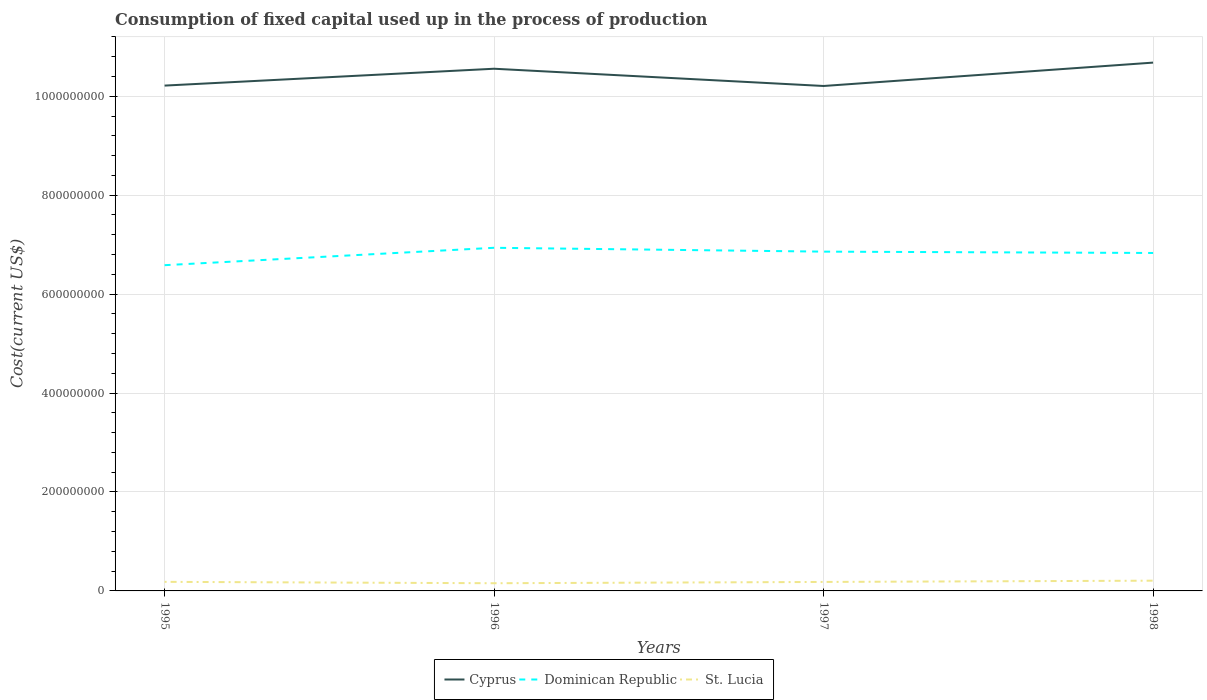Does the line corresponding to Cyprus intersect with the line corresponding to St. Lucia?
Offer a very short reply. No. Across all years, what is the maximum amount consumed in the process of production in Cyprus?
Your answer should be very brief. 1.02e+09. What is the total amount consumed in the process of production in St. Lucia in the graph?
Ensure brevity in your answer.  1.98e+05. What is the difference between the highest and the second highest amount consumed in the process of production in Cyprus?
Give a very brief answer. 4.73e+07. What is the difference between the highest and the lowest amount consumed in the process of production in St. Lucia?
Make the answer very short. 2. Is the amount consumed in the process of production in Cyprus strictly greater than the amount consumed in the process of production in St. Lucia over the years?
Offer a terse response. No. How many years are there in the graph?
Offer a very short reply. 4. What is the difference between two consecutive major ticks on the Y-axis?
Offer a very short reply. 2.00e+08. Are the values on the major ticks of Y-axis written in scientific E-notation?
Your answer should be very brief. No. Where does the legend appear in the graph?
Provide a short and direct response. Bottom center. How many legend labels are there?
Offer a terse response. 3. What is the title of the graph?
Give a very brief answer. Consumption of fixed capital used up in the process of production. Does "Brazil" appear as one of the legend labels in the graph?
Give a very brief answer. No. What is the label or title of the Y-axis?
Give a very brief answer. Cost(current US$). What is the Cost(current US$) in Cyprus in 1995?
Provide a succinct answer. 1.02e+09. What is the Cost(current US$) of Dominican Republic in 1995?
Give a very brief answer. 6.59e+08. What is the Cost(current US$) in St. Lucia in 1995?
Keep it short and to the point. 1.84e+07. What is the Cost(current US$) in Cyprus in 1996?
Your answer should be very brief. 1.06e+09. What is the Cost(current US$) of Dominican Republic in 1996?
Your answer should be very brief. 6.94e+08. What is the Cost(current US$) in St. Lucia in 1996?
Ensure brevity in your answer.  1.55e+07. What is the Cost(current US$) in Cyprus in 1997?
Provide a short and direct response. 1.02e+09. What is the Cost(current US$) in Dominican Republic in 1997?
Your answer should be compact. 6.86e+08. What is the Cost(current US$) in St. Lucia in 1997?
Your answer should be compact. 1.82e+07. What is the Cost(current US$) in Cyprus in 1998?
Your response must be concise. 1.07e+09. What is the Cost(current US$) of Dominican Republic in 1998?
Provide a succinct answer. 6.83e+08. What is the Cost(current US$) in St. Lucia in 1998?
Offer a very short reply. 2.07e+07. Across all years, what is the maximum Cost(current US$) in Cyprus?
Provide a succinct answer. 1.07e+09. Across all years, what is the maximum Cost(current US$) in Dominican Republic?
Make the answer very short. 6.94e+08. Across all years, what is the maximum Cost(current US$) in St. Lucia?
Offer a terse response. 2.07e+07. Across all years, what is the minimum Cost(current US$) in Cyprus?
Your answer should be compact. 1.02e+09. Across all years, what is the minimum Cost(current US$) of Dominican Republic?
Give a very brief answer. 6.59e+08. Across all years, what is the minimum Cost(current US$) of St. Lucia?
Provide a short and direct response. 1.55e+07. What is the total Cost(current US$) of Cyprus in the graph?
Your answer should be very brief. 4.17e+09. What is the total Cost(current US$) in Dominican Republic in the graph?
Your answer should be very brief. 2.72e+09. What is the total Cost(current US$) of St. Lucia in the graph?
Provide a succinct answer. 7.28e+07. What is the difference between the Cost(current US$) in Cyprus in 1995 and that in 1996?
Provide a short and direct response. -3.41e+07. What is the difference between the Cost(current US$) of Dominican Republic in 1995 and that in 1996?
Your answer should be compact. -3.52e+07. What is the difference between the Cost(current US$) of St. Lucia in 1995 and that in 1996?
Offer a terse response. 2.81e+06. What is the difference between the Cost(current US$) of Cyprus in 1995 and that in 1997?
Your response must be concise. 7.90e+05. What is the difference between the Cost(current US$) of Dominican Republic in 1995 and that in 1997?
Offer a terse response. -2.74e+07. What is the difference between the Cost(current US$) of St. Lucia in 1995 and that in 1997?
Your response must be concise. 1.98e+05. What is the difference between the Cost(current US$) in Cyprus in 1995 and that in 1998?
Offer a terse response. -4.65e+07. What is the difference between the Cost(current US$) in Dominican Republic in 1995 and that in 1998?
Offer a terse response. -2.47e+07. What is the difference between the Cost(current US$) of St. Lucia in 1995 and that in 1998?
Ensure brevity in your answer.  -2.37e+06. What is the difference between the Cost(current US$) in Cyprus in 1996 and that in 1997?
Keep it short and to the point. 3.49e+07. What is the difference between the Cost(current US$) in Dominican Republic in 1996 and that in 1997?
Your answer should be very brief. 7.78e+06. What is the difference between the Cost(current US$) in St. Lucia in 1996 and that in 1997?
Your answer should be very brief. -2.61e+06. What is the difference between the Cost(current US$) of Cyprus in 1996 and that in 1998?
Provide a succinct answer. -1.24e+07. What is the difference between the Cost(current US$) of Dominican Republic in 1996 and that in 1998?
Provide a succinct answer. 1.05e+07. What is the difference between the Cost(current US$) of St. Lucia in 1996 and that in 1998?
Provide a short and direct response. -5.18e+06. What is the difference between the Cost(current US$) in Cyprus in 1997 and that in 1998?
Make the answer very short. -4.73e+07. What is the difference between the Cost(current US$) in Dominican Republic in 1997 and that in 1998?
Your answer should be very brief. 2.71e+06. What is the difference between the Cost(current US$) of St. Lucia in 1997 and that in 1998?
Ensure brevity in your answer.  -2.57e+06. What is the difference between the Cost(current US$) of Cyprus in 1995 and the Cost(current US$) of Dominican Republic in 1996?
Your answer should be very brief. 3.28e+08. What is the difference between the Cost(current US$) in Cyprus in 1995 and the Cost(current US$) in St. Lucia in 1996?
Keep it short and to the point. 1.01e+09. What is the difference between the Cost(current US$) of Dominican Republic in 1995 and the Cost(current US$) of St. Lucia in 1996?
Give a very brief answer. 6.43e+08. What is the difference between the Cost(current US$) in Cyprus in 1995 and the Cost(current US$) in Dominican Republic in 1997?
Offer a terse response. 3.36e+08. What is the difference between the Cost(current US$) in Cyprus in 1995 and the Cost(current US$) in St. Lucia in 1997?
Your answer should be compact. 1.00e+09. What is the difference between the Cost(current US$) in Dominican Republic in 1995 and the Cost(current US$) in St. Lucia in 1997?
Make the answer very short. 6.40e+08. What is the difference between the Cost(current US$) in Cyprus in 1995 and the Cost(current US$) in Dominican Republic in 1998?
Provide a succinct answer. 3.38e+08. What is the difference between the Cost(current US$) of Cyprus in 1995 and the Cost(current US$) of St. Lucia in 1998?
Your answer should be very brief. 1.00e+09. What is the difference between the Cost(current US$) of Dominican Republic in 1995 and the Cost(current US$) of St. Lucia in 1998?
Keep it short and to the point. 6.38e+08. What is the difference between the Cost(current US$) of Cyprus in 1996 and the Cost(current US$) of Dominican Republic in 1997?
Offer a terse response. 3.70e+08. What is the difference between the Cost(current US$) in Cyprus in 1996 and the Cost(current US$) in St. Lucia in 1997?
Keep it short and to the point. 1.04e+09. What is the difference between the Cost(current US$) in Dominican Republic in 1996 and the Cost(current US$) in St. Lucia in 1997?
Give a very brief answer. 6.76e+08. What is the difference between the Cost(current US$) in Cyprus in 1996 and the Cost(current US$) in Dominican Republic in 1998?
Your response must be concise. 3.72e+08. What is the difference between the Cost(current US$) of Cyprus in 1996 and the Cost(current US$) of St. Lucia in 1998?
Offer a terse response. 1.03e+09. What is the difference between the Cost(current US$) of Dominican Republic in 1996 and the Cost(current US$) of St. Lucia in 1998?
Ensure brevity in your answer.  6.73e+08. What is the difference between the Cost(current US$) of Cyprus in 1997 and the Cost(current US$) of Dominican Republic in 1998?
Give a very brief answer. 3.38e+08. What is the difference between the Cost(current US$) of Cyprus in 1997 and the Cost(current US$) of St. Lucia in 1998?
Provide a succinct answer. 1.00e+09. What is the difference between the Cost(current US$) in Dominican Republic in 1997 and the Cost(current US$) in St. Lucia in 1998?
Provide a succinct answer. 6.65e+08. What is the average Cost(current US$) in Cyprus per year?
Give a very brief answer. 1.04e+09. What is the average Cost(current US$) in Dominican Republic per year?
Keep it short and to the point. 6.80e+08. What is the average Cost(current US$) of St. Lucia per year?
Offer a terse response. 1.82e+07. In the year 1995, what is the difference between the Cost(current US$) of Cyprus and Cost(current US$) of Dominican Republic?
Your answer should be compact. 3.63e+08. In the year 1995, what is the difference between the Cost(current US$) of Cyprus and Cost(current US$) of St. Lucia?
Your answer should be compact. 1.00e+09. In the year 1995, what is the difference between the Cost(current US$) of Dominican Republic and Cost(current US$) of St. Lucia?
Offer a very short reply. 6.40e+08. In the year 1996, what is the difference between the Cost(current US$) of Cyprus and Cost(current US$) of Dominican Republic?
Make the answer very short. 3.62e+08. In the year 1996, what is the difference between the Cost(current US$) in Cyprus and Cost(current US$) in St. Lucia?
Offer a terse response. 1.04e+09. In the year 1996, what is the difference between the Cost(current US$) of Dominican Republic and Cost(current US$) of St. Lucia?
Ensure brevity in your answer.  6.78e+08. In the year 1997, what is the difference between the Cost(current US$) of Cyprus and Cost(current US$) of Dominican Republic?
Ensure brevity in your answer.  3.35e+08. In the year 1997, what is the difference between the Cost(current US$) of Cyprus and Cost(current US$) of St. Lucia?
Your answer should be compact. 1.00e+09. In the year 1997, what is the difference between the Cost(current US$) in Dominican Republic and Cost(current US$) in St. Lucia?
Your response must be concise. 6.68e+08. In the year 1998, what is the difference between the Cost(current US$) of Cyprus and Cost(current US$) of Dominican Republic?
Provide a short and direct response. 3.85e+08. In the year 1998, what is the difference between the Cost(current US$) of Cyprus and Cost(current US$) of St. Lucia?
Give a very brief answer. 1.05e+09. In the year 1998, what is the difference between the Cost(current US$) of Dominican Republic and Cost(current US$) of St. Lucia?
Your answer should be compact. 6.62e+08. What is the ratio of the Cost(current US$) in Dominican Republic in 1995 to that in 1996?
Your answer should be very brief. 0.95. What is the ratio of the Cost(current US$) of St. Lucia in 1995 to that in 1996?
Your answer should be very brief. 1.18. What is the ratio of the Cost(current US$) of Dominican Republic in 1995 to that in 1997?
Give a very brief answer. 0.96. What is the ratio of the Cost(current US$) of St. Lucia in 1995 to that in 1997?
Your answer should be very brief. 1.01. What is the ratio of the Cost(current US$) in Cyprus in 1995 to that in 1998?
Ensure brevity in your answer.  0.96. What is the ratio of the Cost(current US$) of Dominican Republic in 1995 to that in 1998?
Provide a succinct answer. 0.96. What is the ratio of the Cost(current US$) of St. Lucia in 1995 to that in 1998?
Make the answer very short. 0.89. What is the ratio of the Cost(current US$) in Cyprus in 1996 to that in 1997?
Offer a terse response. 1.03. What is the ratio of the Cost(current US$) of Dominican Republic in 1996 to that in 1997?
Your response must be concise. 1.01. What is the ratio of the Cost(current US$) of St. Lucia in 1996 to that in 1997?
Keep it short and to the point. 0.86. What is the ratio of the Cost(current US$) of Cyprus in 1996 to that in 1998?
Keep it short and to the point. 0.99. What is the ratio of the Cost(current US$) in Dominican Republic in 1996 to that in 1998?
Your answer should be compact. 1.02. What is the ratio of the Cost(current US$) in St. Lucia in 1996 to that in 1998?
Provide a short and direct response. 0.75. What is the ratio of the Cost(current US$) in Cyprus in 1997 to that in 1998?
Make the answer very short. 0.96. What is the ratio of the Cost(current US$) of St. Lucia in 1997 to that in 1998?
Provide a short and direct response. 0.88. What is the difference between the highest and the second highest Cost(current US$) of Cyprus?
Keep it short and to the point. 1.24e+07. What is the difference between the highest and the second highest Cost(current US$) of Dominican Republic?
Provide a succinct answer. 7.78e+06. What is the difference between the highest and the second highest Cost(current US$) of St. Lucia?
Give a very brief answer. 2.37e+06. What is the difference between the highest and the lowest Cost(current US$) in Cyprus?
Your answer should be compact. 4.73e+07. What is the difference between the highest and the lowest Cost(current US$) of Dominican Republic?
Keep it short and to the point. 3.52e+07. What is the difference between the highest and the lowest Cost(current US$) in St. Lucia?
Your answer should be compact. 5.18e+06. 